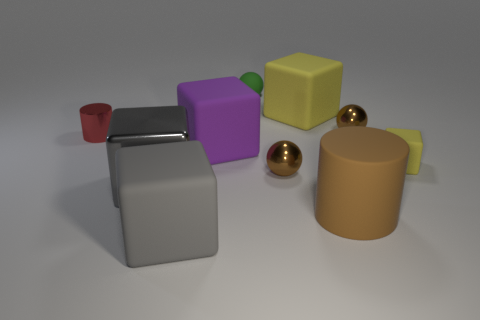What shape is the small red metal thing?
Your answer should be very brief. Cylinder. There is a shiny thing that is both behind the large purple rubber cube and to the left of the purple rubber cube; what is its size?
Offer a terse response. Small. There is a yellow thing to the right of the big cylinder; what is its material?
Keep it short and to the point. Rubber. Is the color of the big shiny block the same as the big block in front of the big shiny thing?
Your answer should be very brief. Yes. How many objects are either cubes that are to the left of the big purple rubber object or tiny spheres in front of the tiny rubber cube?
Offer a very short reply. 3. There is a big rubber object that is on the right side of the tiny green matte sphere and behind the big shiny thing; what color is it?
Give a very brief answer. Yellow. Are there more small yellow blocks than yellow things?
Keep it short and to the point. No. There is a big gray thing that is behind the large cylinder; is its shape the same as the purple matte thing?
Ensure brevity in your answer.  Yes. How many matte objects are tiny brown spheres or brown cylinders?
Offer a very short reply. 1. Are there any big cylinders that have the same material as the tiny green thing?
Offer a very short reply. Yes. 